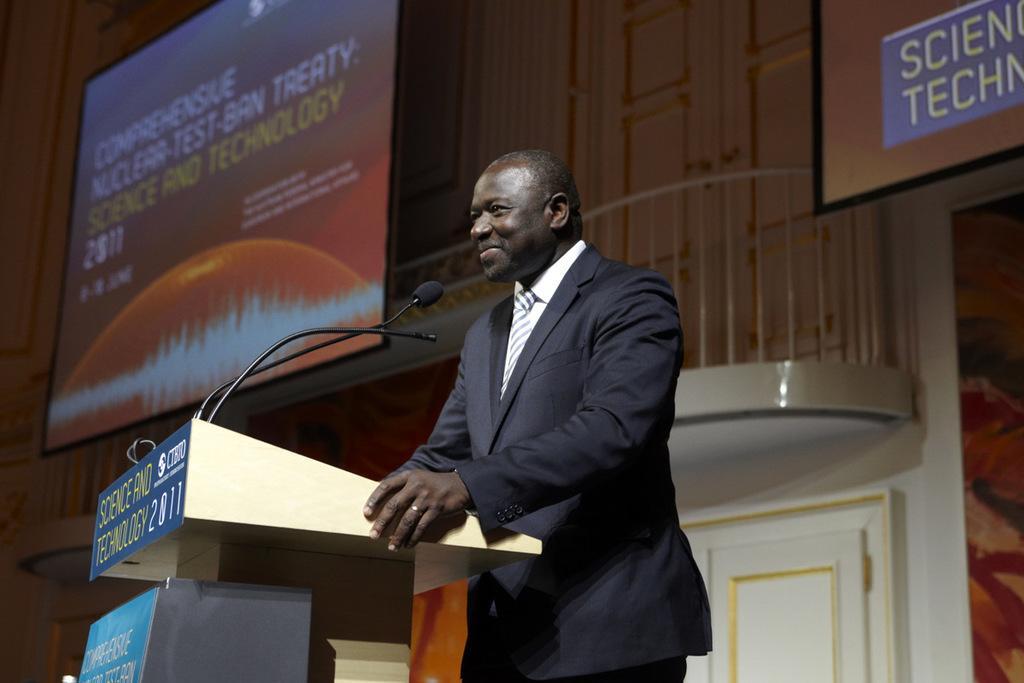Please provide a concise description of this image. In this image we can see a person standing in front of the podium, on the podium, we can see a mic and a board with some text, also we can see the screens. 